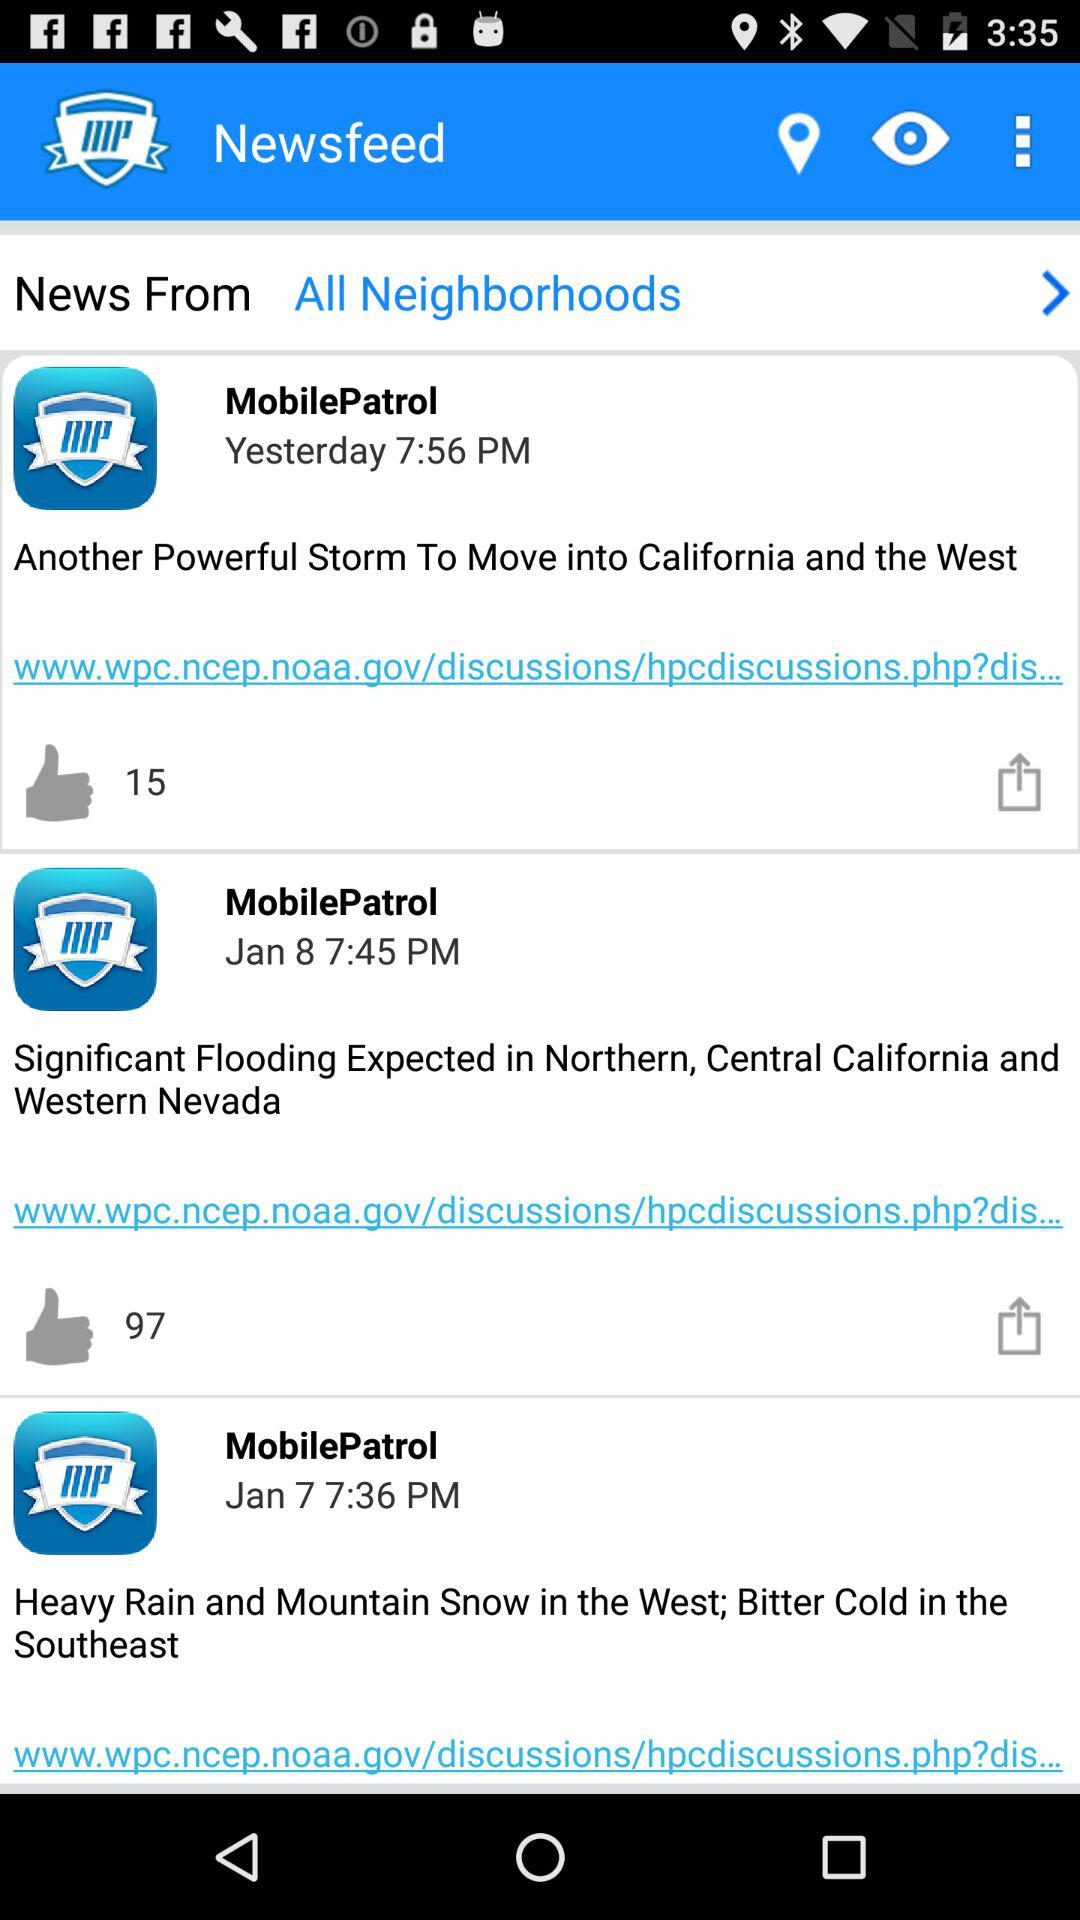How many news items are there in the newsfeed?
Answer the question using a single word or phrase. 3 